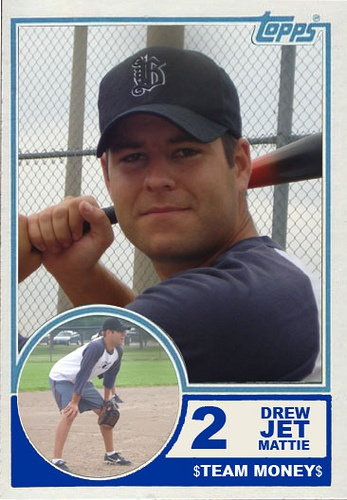Describe the objects in this image and their specific colors. I can see people in white, black, maroon, and gray tones, people in white, gray, lavender, and darkgray tones, baseball bat in white, black, gray, maroon, and brown tones, baseball glove in white, gray, darkgray, and black tones, and car in white, darkgray, lightgray, and gray tones in this image. 